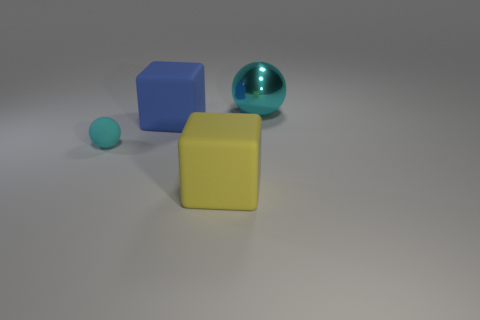There is a blue cube that is the same size as the metallic sphere; what material is it? rubber 